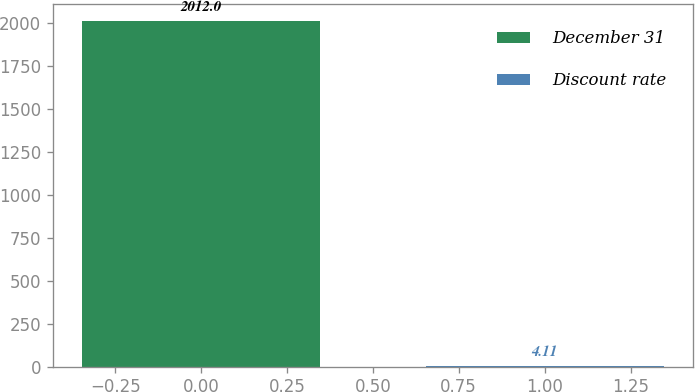Convert chart to OTSL. <chart><loc_0><loc_0><loc_500><loc_500><bar_chart><fcel>December 31<fcel>Discount rate<nl><fcel>2012<fcel>4.11<nl></chart> 